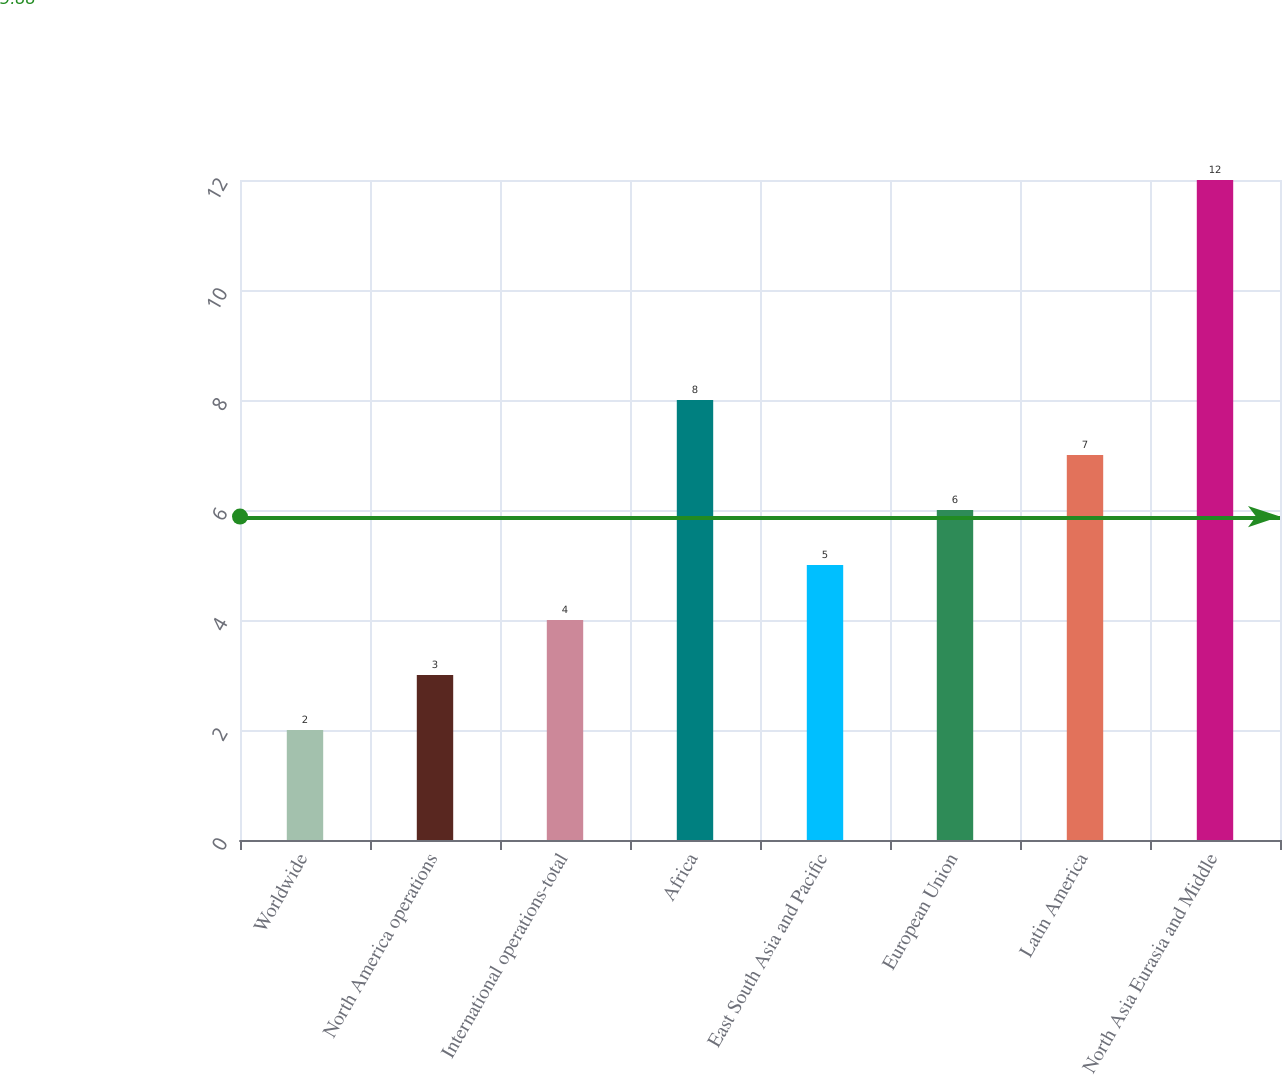Convert chart to OTSL. <chart><loc_0><loc_0><loc_500><loc_500><bar_chart><fcel>Worldwide<fcel>North America operations<fcel>International operations-total<fcel>Africa<fcel>East South Asia and Pacific<fcel>European Union<fcel>Latin America<fcel>North Asia Eurasia and Middle<nl><fcel>2<fcel>3<fcel>4<fcel>8<fcel>5<fcel>6<fcel>7<fcel>12<nl></chart> 